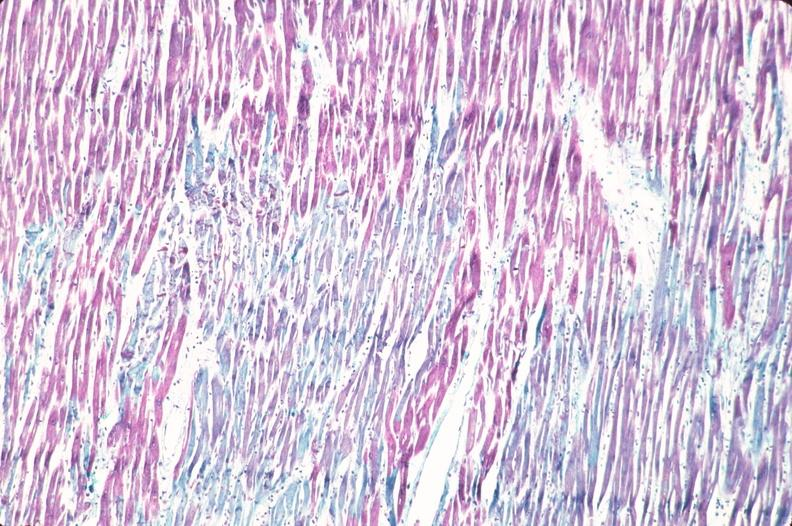does lesion show heart, acute myocardial infarction?
Answer the question using a single word or phrase. No 